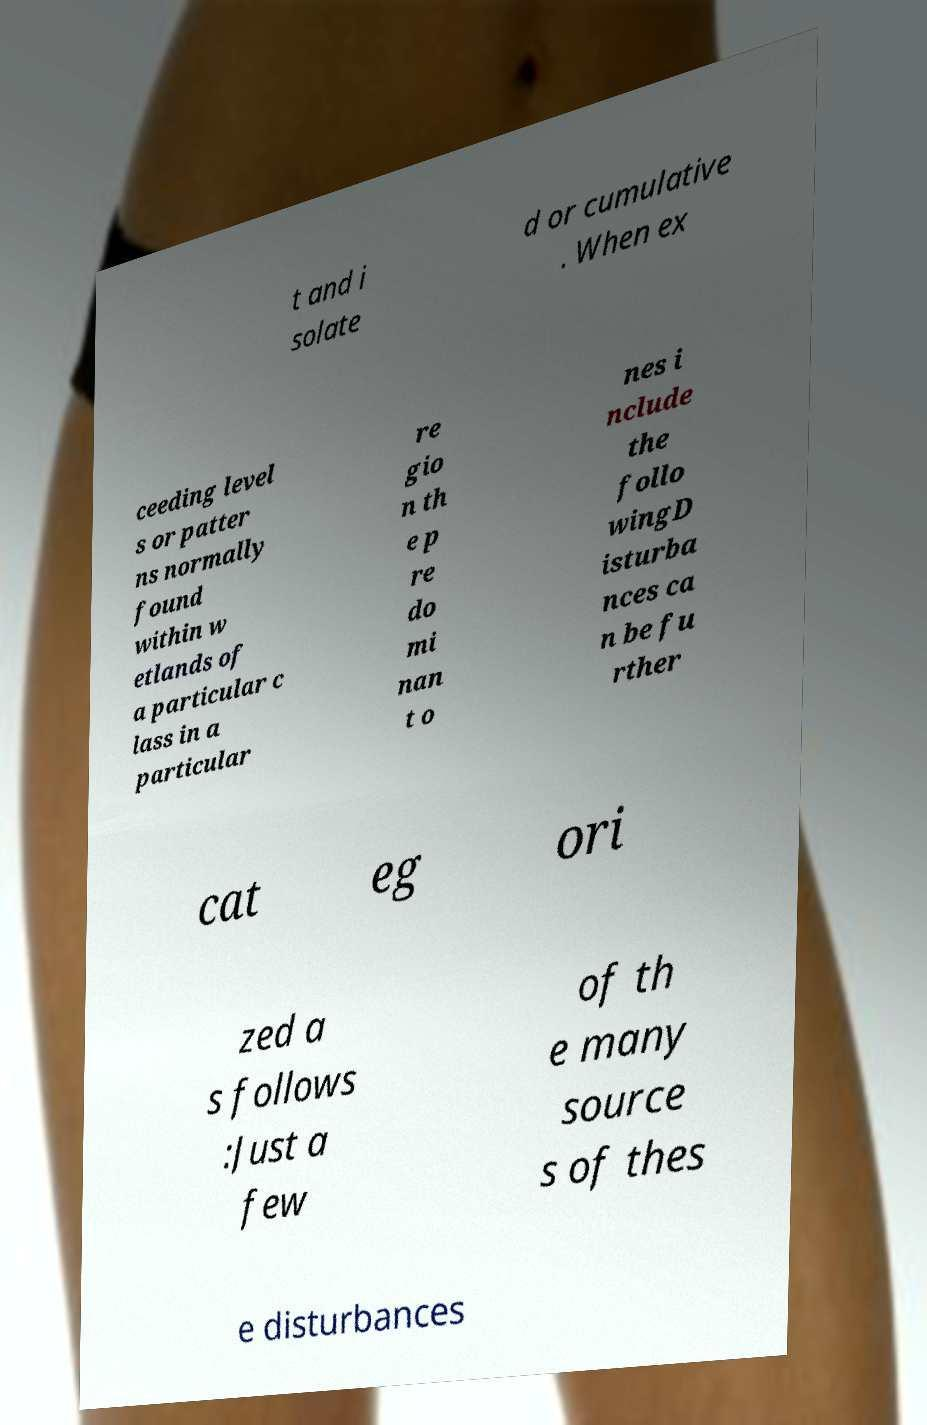Could you assist in decoding the text presented in this image and type it out clearly? t and i solate d or cumulative . When ex ceeding level s or patter ns normally found within w etlands of a particular c lass in a particular re gio n th e p re do mi nan t o nes i nclude the follo wingD isturba nces ca n be fu rther cat eg ori zed a s follows :Just a few of th e many source s of thes e disturbances 